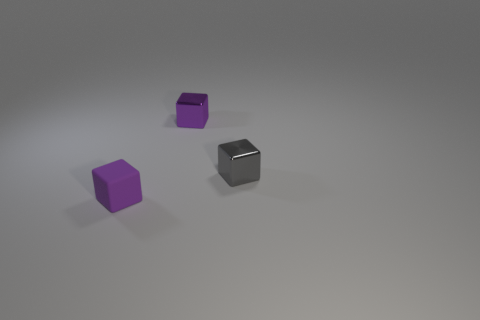Add 1 tiny matte objects. How many objects exist? 4 Add 2 small purple shiny blocks. How many small purple shiny blocks are left? 3 Add 3 cubes. How many cubes exist? 6 Subtract 0 cyan cylinders. How many objects are left? 3 Subtract all tiny matte things. Subtract all tiny rubber things. How many objects are left? 1 